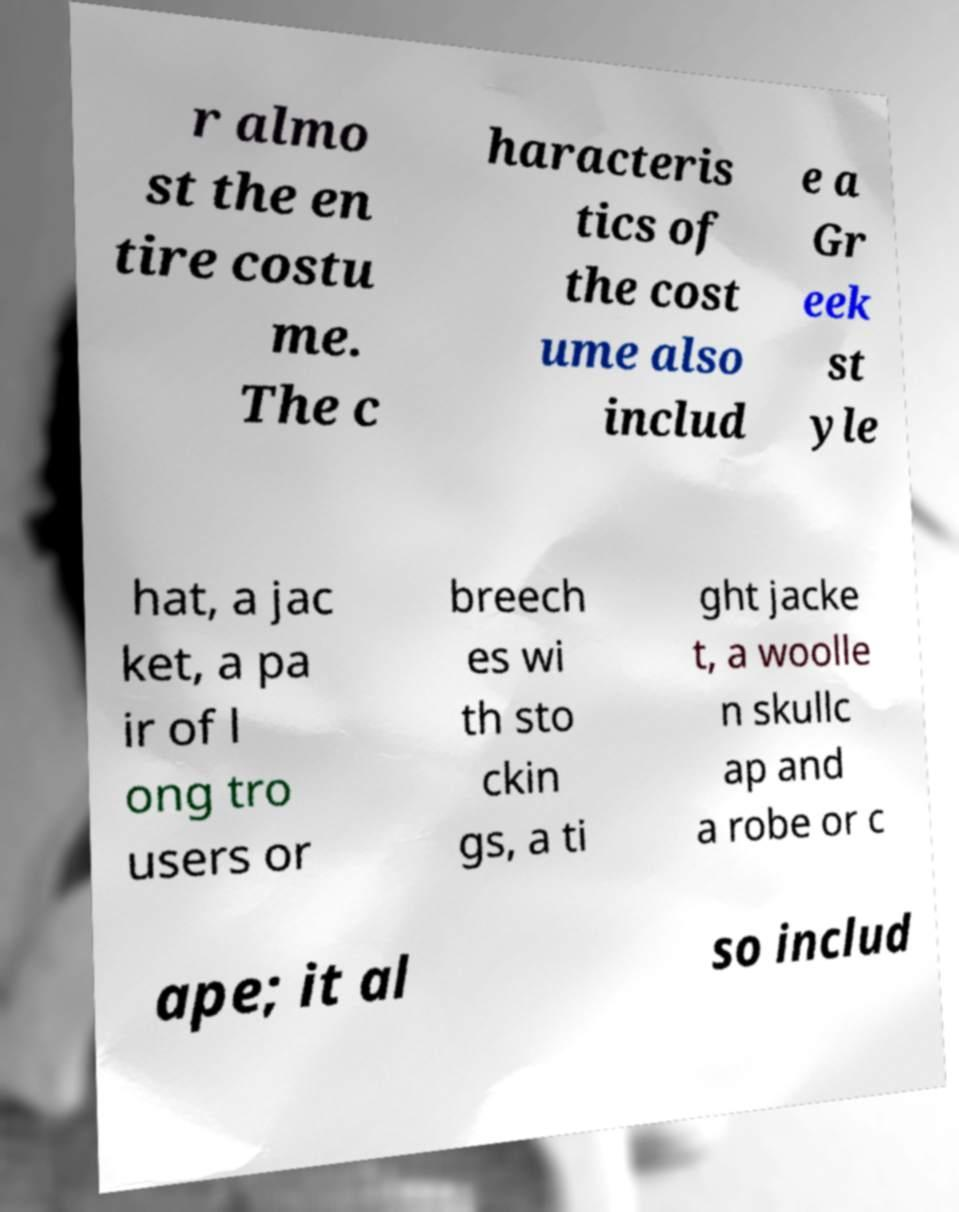There's text embedded in this image that I need extracted. Can you transcribe it verbatim? r almo st the en tire costu me. The c haracteris tics of the cost ume also includ e a Gr eek st yle hat, a jac ket, a pa ir of l ong tro users or breech es wi th sto ckin gs, a ti ght jacke t, a woolle n skullc ap and a robe or c ape; it al so includ 